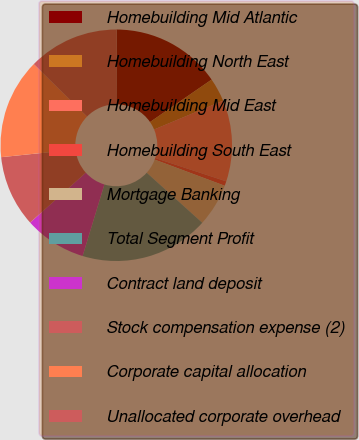Convert chart to OTSL. <chart><loc_0><loc_0><loc_500><loc_500><pie_chart><fcel>Homebuilding Mid Atlantic<fcel>Homebuilding North East<fcel>Homebuilding Mid East<fcel>Homebuilding South East<fcel>Mortgage Banking<fcel>Total Segment Profit<fcel>Contract land deposit<fcel>Stock compensation expense (2)<fcel>Corporate capital allocation<fcel>Unallocated corporate overhead<nl><fcel>15.35%<fcel>3.31%<fcel>11.34%<fcel>0.64%<fcel>5.99%<fcel>18.03%<fcel>8.66%<fcel>10.0%<fcel>14.01%<fcel>12.68%<nl></chart> 